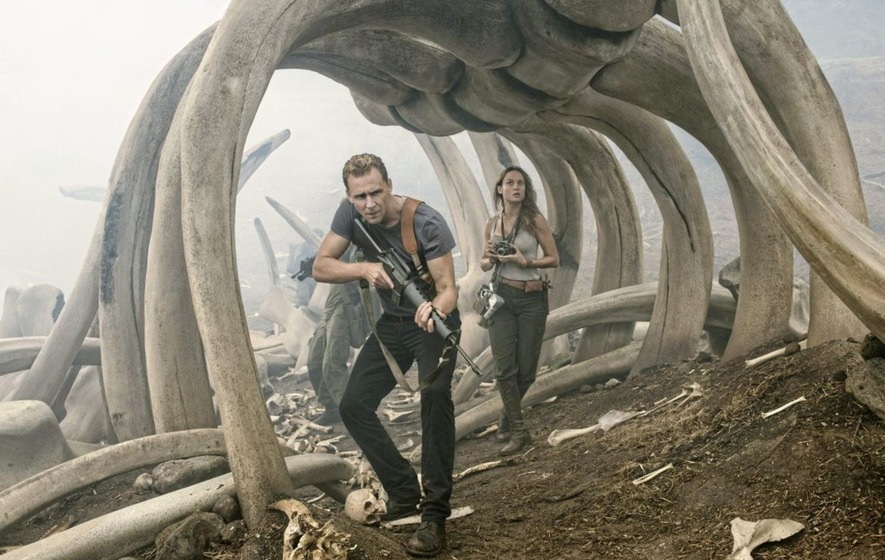Imagine what might happen next in this scene. Get creative! Suddenly, the ground begins to tremble as a deep, resonating roar echoes through the valley. Out of the mist, a massive, shadowy figure starts to emerge, its lumbering footsteps causing the bones overhead to shake and rattle. The characters freeze momentarily, their eyes widening as they realize they are about to come face-to-face with one of the ancient creatures they feared might still inhabit this land. Captain James Conrad grips his machete tighter, while Mason Weaver readies her camera, the tension palpable as they prepare to encounter the towering beast. 